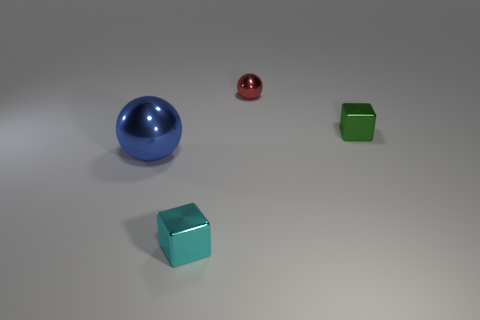Add 3 cyan metal blocks. How many objects exist? 7 Subtract 1 blocks. How many blocks are left? 1 Subtract all blue blocks. Subtract all green cylinders. How many blocks are left? 2 Subtract all blocks. Subtract all blocks. How many objects are left? 0 Add 4 large metal things. How many large metal things are left? 5 Add 4 green matte cylinders. How many green matte cylinders exist? 4 Subtract 0 gray cylinders. How many objects are left? 4 